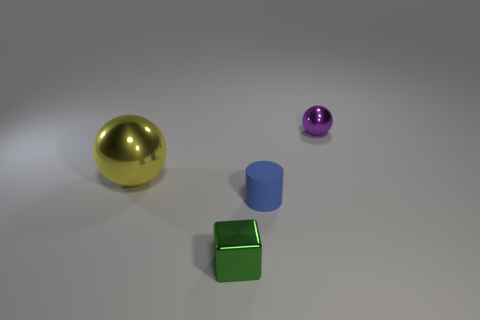Add 1 yellow things. How many objects exist? 5 Subtract all cubes. How many objects are left? 3 Subtract all tiny green objects. Subtract all tiny green shiny blocks. How many objects are left? 2 Add 4 purple metal things. How many purple metal things are left? 5 Add 1 large shiny balls. How many large shiny balls exist? 2 Subtract 1 green blocks. How many objects are left? 3 